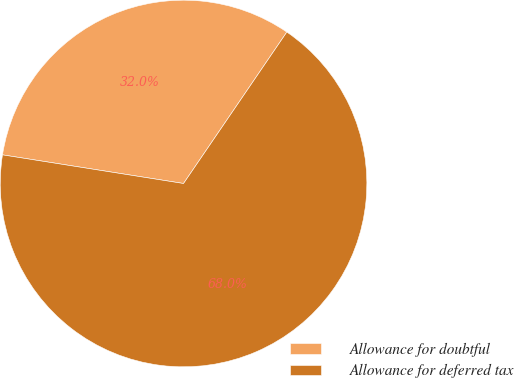Convert chart to OTSL. <chart><loc_0><loc_0><loc_500><loc_500><pie_chart><fcel>Allowance for doubtful<fcel>Allowance for deferred tax<nl><fcel>32.03%<fcel>67.97%<nl></chart> 